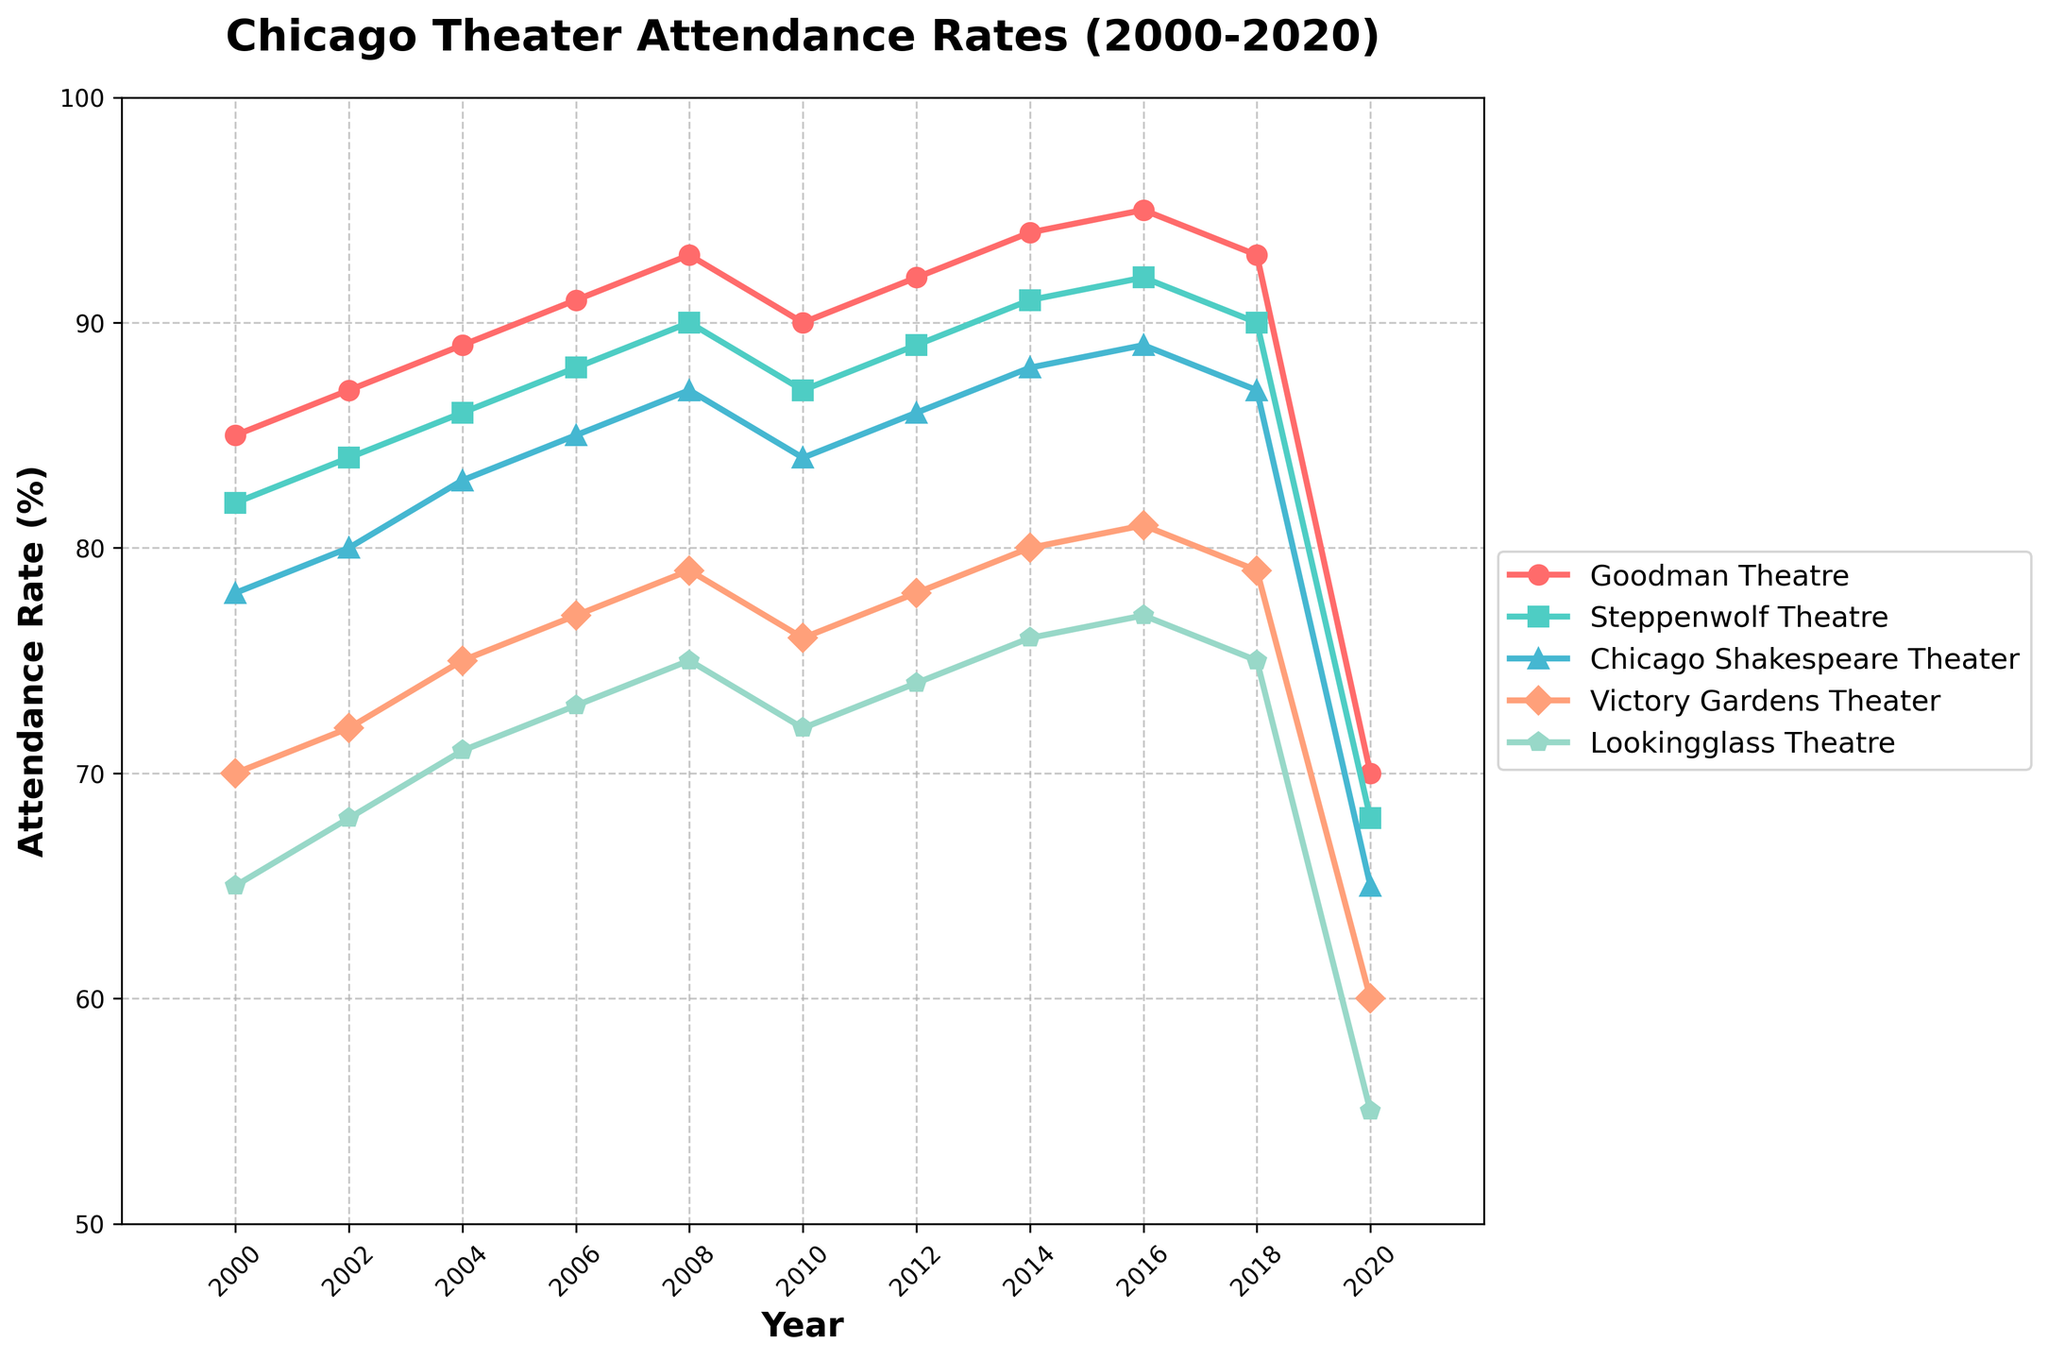What's the trend for Goodman Theatre's attendance rate from 2000 to 2020? Compare the Goodman Theatre's data points over the years. Attendance rates increase gradually from 85% in 2000 to 95% in 2016, then fall sharply to 70% in 2020.
Answer: Increasing until 2016, then decreasing sharply in 2020 Which theater had the highest attendance rate in 2006? Look at the data points for each theater in 2006. Goodman Theatre has the highest rate at 91%.
Answer: Goodman Theatre How did the attendance rates of Victory Gardens Theater and Lookingglass Theatre compare in 2002? Compare the 2002 data for both theaters: Victory Gardens Theater is at 72% and Lookingglass Theatre is at 68%.
Answer: Victory Gardens Theater had a higher rate By how much did Chicago Shakespeare Theater's attendance rate change between 2000 and 2020? Calculate the difference between the attendance rates in 2020 (65%) and 2000 (78%): 78% - 65% = 13%.
Answer: Decreased by 13% What’s the average attendance rate of Steppenwolf Theatre from 2000 to 2020? Find the average of all recorded attendance rates: (82 + 84 + 86 + 88 + 90 + 87 + 89 + 91 + 92 + 90 + 68) / 11 ≈ 86%.
Answer: Approximately 86% Which theater experienced the largest decline in attendance rate in 2020 compared to 2018? Compare the differences for each theater: 
Goodman Theatre: 93% - 70% = 23%
Steppenwolf Theatre: 90% - 68% = 22%
Chicago Shakespeare Theater: 87% - 65% = 22%
Victory Gardens Theater: 79% - 60% = 19%
Lookingglass Theatre: 75% - 55% = 20%
Goodman Theatre has the largest decline of 23%.
Answer: Goodman Theatre How does Steppenwolf Theatre’s attendance rate in 2018 compare to Chicago Shakespeare Theater’s attendance rate in 2016? Compare the values: Steppenwolf Theatre’s rate in 2018 is 90%, and Chicago Shakespeare Theater’s rate in 2016 is 89%.
Answer: Slightly higher in 2018 for Steppenwolf Theatre Which theater had a consistently increasing attendance rate from 2000 to 2014? Identify theaters with no decrease in rates from 2000 to 2014: Goodman Theatre and Steppenwolf Theatre have consistent increases.
Answer: Goodman Theatre and Steppenwolf Theatre What color is used to represent Victory Gardens Theater? Look at the visual attributes in the plot legend: Victory Gardens Theater is represented by an orange line.
Answer: Orange 